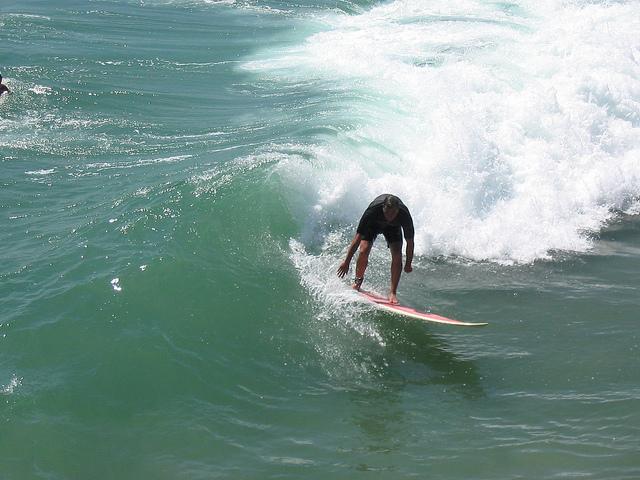How can he stand that far forward?
Quick response, please. Balance. Is the person wearing the wetsuit?
Be succinct. Yes. What activity is this person participating in?
Give a very brief answer. Surfing. What is he doing?
Quick response, please. Surfing. Why is the man bent over on the surfboard?
Quick response, please. Balance. What is the color of the water?
Write a very short answer. Green. 